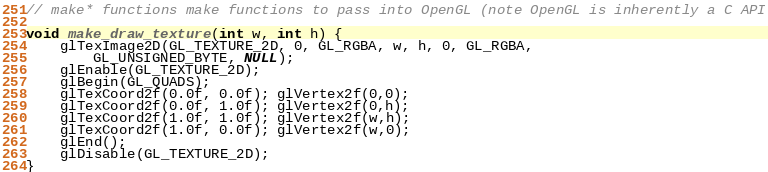<code> <loc_0><loc_0><loc_500><loc_500><_Cuda_>
// make* functions make functions to pass into OpenGL (note OpenGL is inherently a C API

void make_draw_texture(int w, int h) {
	glTexImage2D(GL_TEXTURE_2D, 0, GL_RGBA, w, h, 0, GL_RGBA, 
		GL_UNSIGNED_BYTE, NULL);
	glEnable(GL_TEXTURE_2D);
	glBegin(GL_QUADS);
	glTexCoord2f(0.0f, 0.0f); glVertex2f(0,0);
	glTexCoord2f(0.0f, 1.0f); glVertex2f(0,h);
	glTexCoord2f(1.0f, 1.0f); glVertex2f(w,h);
	glTexCoord2f(1.0f, 0.0f); glVertex2f(w,0);
	glEnd();
	glDisable(GL_TEXTURE_2D);
}	
</code> 